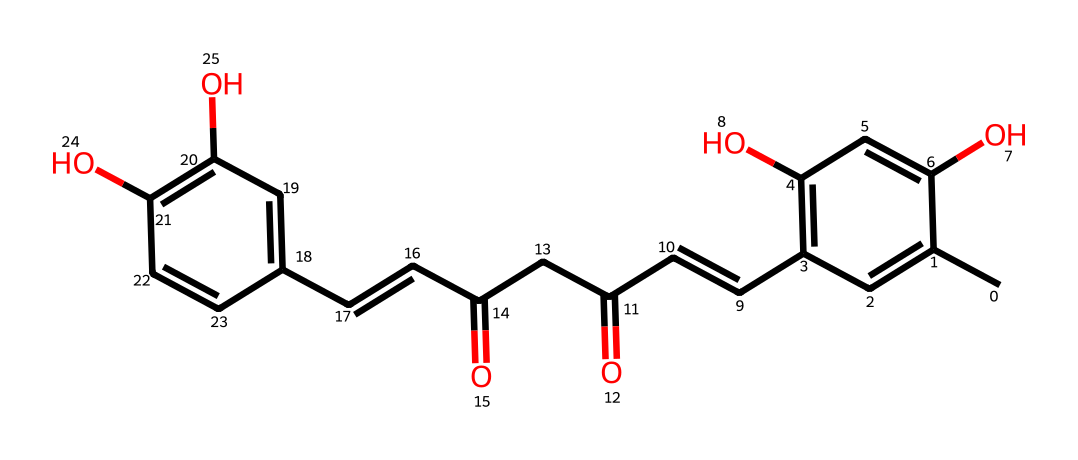How many hydroxyl groups are in the structure? There are two -OH groups visible in the chemical structure, represented by the two oxygen atoms bonded to hydrogen atoms, indicating the presence of hydroxyl groups.
Answer: two What is the main functional group in curcumin's structure? The main functional group in this structure is the diketone, evidenced by the two carbonyl groups (C=O) present at different positions. These contribute significantly to its chemical behavior and properties.
Answer: diketone How many double bonds are present in the structure? By examining the chemical structure, we can identify that there are five double bonds present between various carbon atoms throughout the structure.
Answer: five What type of isomerism can curcumin exhibit due to its structure? Curcumin's structure contains multiple stereocenters, which allows it to exhibit geometric isomerism, specifically cis-trans isomerism around the double bonds. This characteristic means that the arrangement of atoms can lead to different spatial configurations.
Answer: geometric isomerism What is the total number of rings in the molecular structure? Analyzing the structure visually shows that there are no defined rings present; all carbon atoms are part of an extended chain and double-bond connections, indicating it does not have ring structures.
Answer: zero 